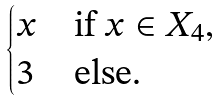<formula> <loc_0><loc_0><loc_500><loc_500>\begin{cases} x & \text {if } x \in X _ { 4 } , \\ 3 & \text {else.} \end{cases}</formula> 